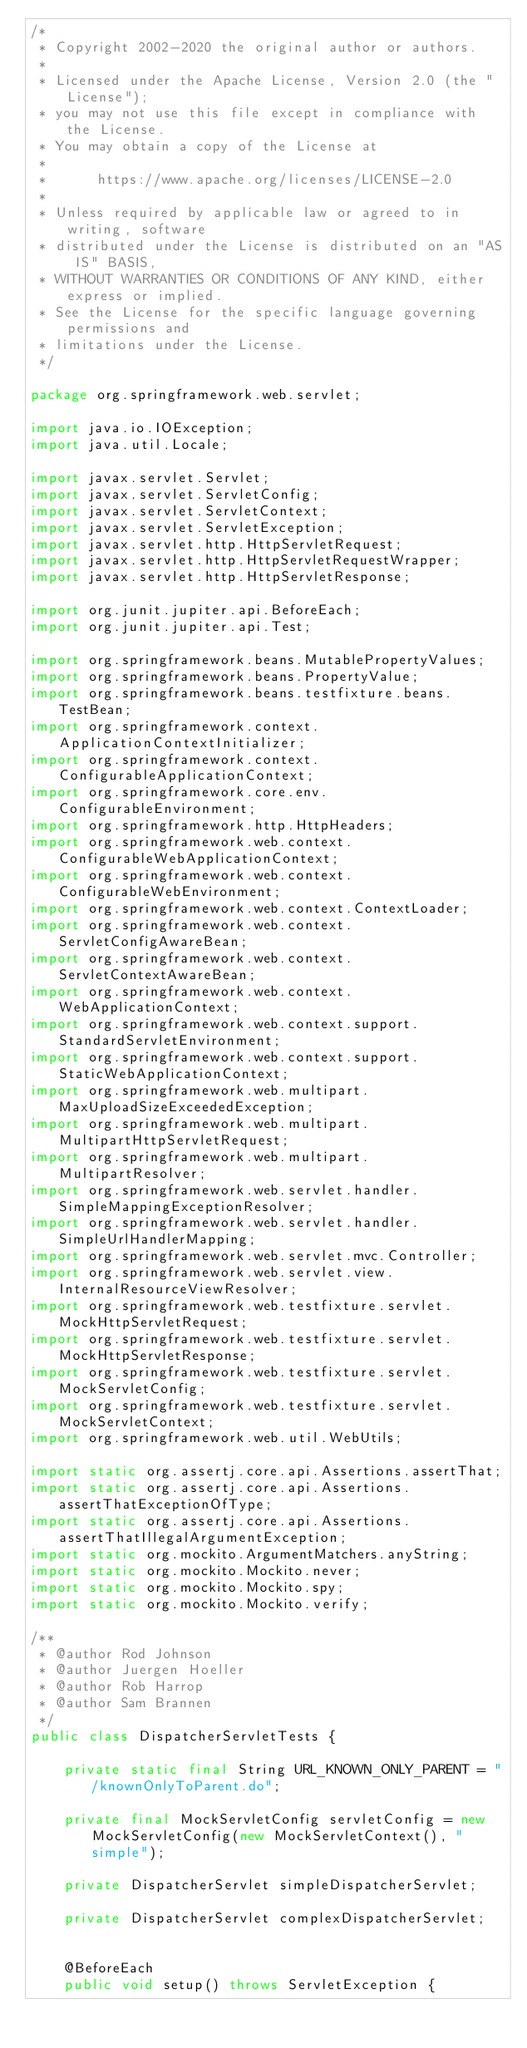Convert code to text. <code><loc_0><loc_0><loc_500><loc_500><_Java_>/*
 * Copyright 2002-2020 the original author or authors.
 *
 * Licensed under the Apache License, Version 2.0 (the "License");
 * you may not use this file except in compliance with the License.
 * You may obtain a copy of the License at
 *
 *      https://www.apache.org/licenses/LICENSE-2.0
 *
 * Unless required by applicable law or agreed to in writing, software
 * distributed under the License is distributed on an "AS IS" BASIS,
 * WITHOUT WARRANTIES OR CONDITIONS OF ANY KIND, either express or implied.
 * See the License for the specific language governing permissions and
 * limitations under the License.
 */

package org.springframework.web.servlet;

import java.io.IOException;
import java.util.Locale;

import javax.servlet.Servlet;
import javax.servlet.ServletConfig;
import javax.servlet.ServletContext;
import javax.servlet.ServletException;
import javax.servlet.http.HttpServletRequest;
import javax.servlet.http.HttpServletRequestWrapper;
import javax.servlet.http.HttpServletResponse;

import org.junit.jupiter.api.BeforeEach;
import org.junit.jupiter.api.Test;

import org.springframework.beans.MutablePropertyValues;
import org.springframework.beans.PropertyValue;
import org.springframework.beans.testfixture.beans.TestBean;
import org.springframework.context.ApplicationContextInitializer;
import org.springframework.context.ConfigurableApplicationContext;
import org.springframework.core.env.ConfigurableEnvironment;
import org.springframework.http.HttpHeaders;
import org.springframework.web.context.ConfigurableWebApplicationContext;
import org.springframework.web.context.ConfigurableWebEnvironment;
import org.springframework.web.context.ContextLoader;
import org.springframework.web.context.ServletConfigAwareBean;
import org.springframework.web.context.ServletContextAwareBean;
import org.springframework.web.context.WebApplicationContext;
import org.springframework.web.context.support.StandardServletEnvironment;
import org.springframework.web.context.support.StaticWebApplicationContext;
import org.springframework.web.multipart.MaxUploadSizeExceededException;
import org.springframework.web.multipart.MultipartHttpServletRequest;
import org.springframework.web.multipart.MultipartResolver;
import org.springframework.web.servlet.handler.SimpleMappingExceptionResolver;
import org.springframework.web.servlet.handler.SimpleUrlHandlerMapping;
import org.springframework.web.servlet.mvc.Controller;
import org.springframework.web.servlet.view.InternalResourceViewResolver;
import org.springframework.web.testfixture.servlet.MockHttpServletRequest;
import org.springframework.web.testfixture.servlet.MockHttpServletResponse;
import org.springframework.web.testfixture.servlet.MockServletConfig;
import org.springframework.web.testfixture.servlet.MockServletContext;
import org.springframework.web.util.WebUtils;

import static org.assertj.core.api.Assertions.assertThat;
import static org.assertj.core.api.Assertions.assertThatExceptionOfType;
import static org.assertj.core.api.Assertions.assertThatIllegalArgumentException;
import static org.mockito.ArgumentMatchers.anyString;
import static org.mockito.Mockito.never;
import static org.mockito.Mockito.spy;
import static org.mockito.Mockito.verify;

/**
 * @author Rod Johnson
 * @author Juergen Hoeller
 * @author Rob Harrop
 * @author Sam Brannen
 */
public class DispatcherServletTests {

	private static final String URL_KNOWN_ONLY_PARENT = "/knownOnlyToParent.do";

	private final MockServletConfig servletConfig = new MockServletConfig(new MockServletContext(), "simple");

	private DispatcherServlet simpleDispatcherServlet;

	private DispatcherServlet complexDispatcherServlet;


	@BeforeEach
	public void setup() throws ServletException {</code> 